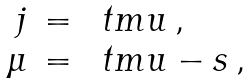Convert formula to latex. <formula><loc_0><loc_0><loc_500><loc_500>\begin{array} { r c l } j & = & \ t m u \, , \\ \mu & = & \ t m u - s \, , \end{array}</formula> 